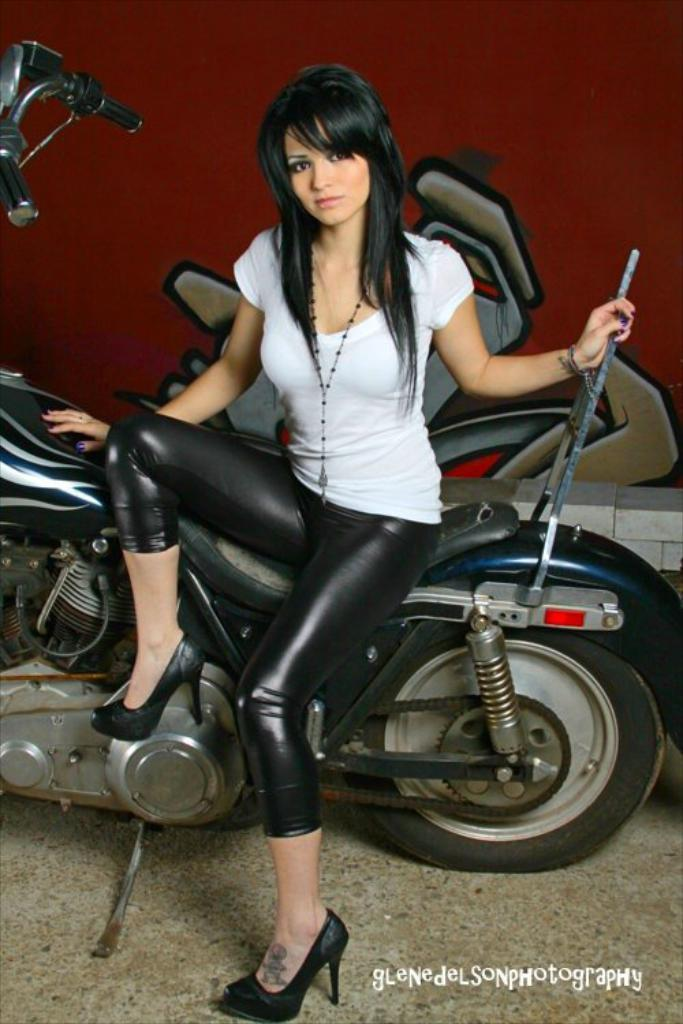What is the woman in the image doing? The woman is sitting on a bike. What is the woman holding in the image? The woman is holding a rod of the bike. What is the woman wearing in the image? The woman is wearing a white shirt and black pants. What type of footwear is the woman wearing in the image? The woman is wearing heels. What type of needle is the woman using to sew a shirt in the image? There is no needle or shirt present in the image; the woman is sitting on a bike and holding a rod of the bike. --- Transcript: In this image we can see a man is standing near a car and he is holding a key in his hand. Facts: 1. There is a man in the image. 2. The man is standing near a car. 3. The man is holding a key in his hand. Conversation: Who is in the image? There is a man in the image. What is the man doing in the image? The man is standing near a car. What is the man holding in the image? The man is holding a key in his hand. Reasoning: Let's think step by step in order to produce the conversation. We start by identifying the main subject in the image, which is the man. Then, we expand the conversation to include other details about the man, such as what he is doing and what he is holding. Each question is designed to elicit a specific detail about the image that is known from the provided facts. Absurd Question/Answer: What type of hammer is the man using to fix the car in the image? There is no hammer present in the image; the man is simply standing near a car and holding a key in his hand. --- Transcript: In this picture we can see a cat is sitting on the chair and there is a bowl of food on the table. Facts: 1. There is a cat in the image. 2. The cat is sitting on a chair. 3. There is a bowl of food in the image. 4. The bowl of food is on a table. Conversation: What animal is in the image? There is a cat in the image. What is the cat doing in the image? The cat is sitting on a chair. What is present on the table in the image? There is a bowl of food on the table. Reasoning: Let's think step by step in order to produce the conversation. We start by identifying the main subject in the image, which is the cat. Then, we expand the conversation to include other details about the cat, such as what it is doing, and other objects in the image, such as the bowl of food on the table. Each question is designed to elicit a specific detail about the image that is known from 